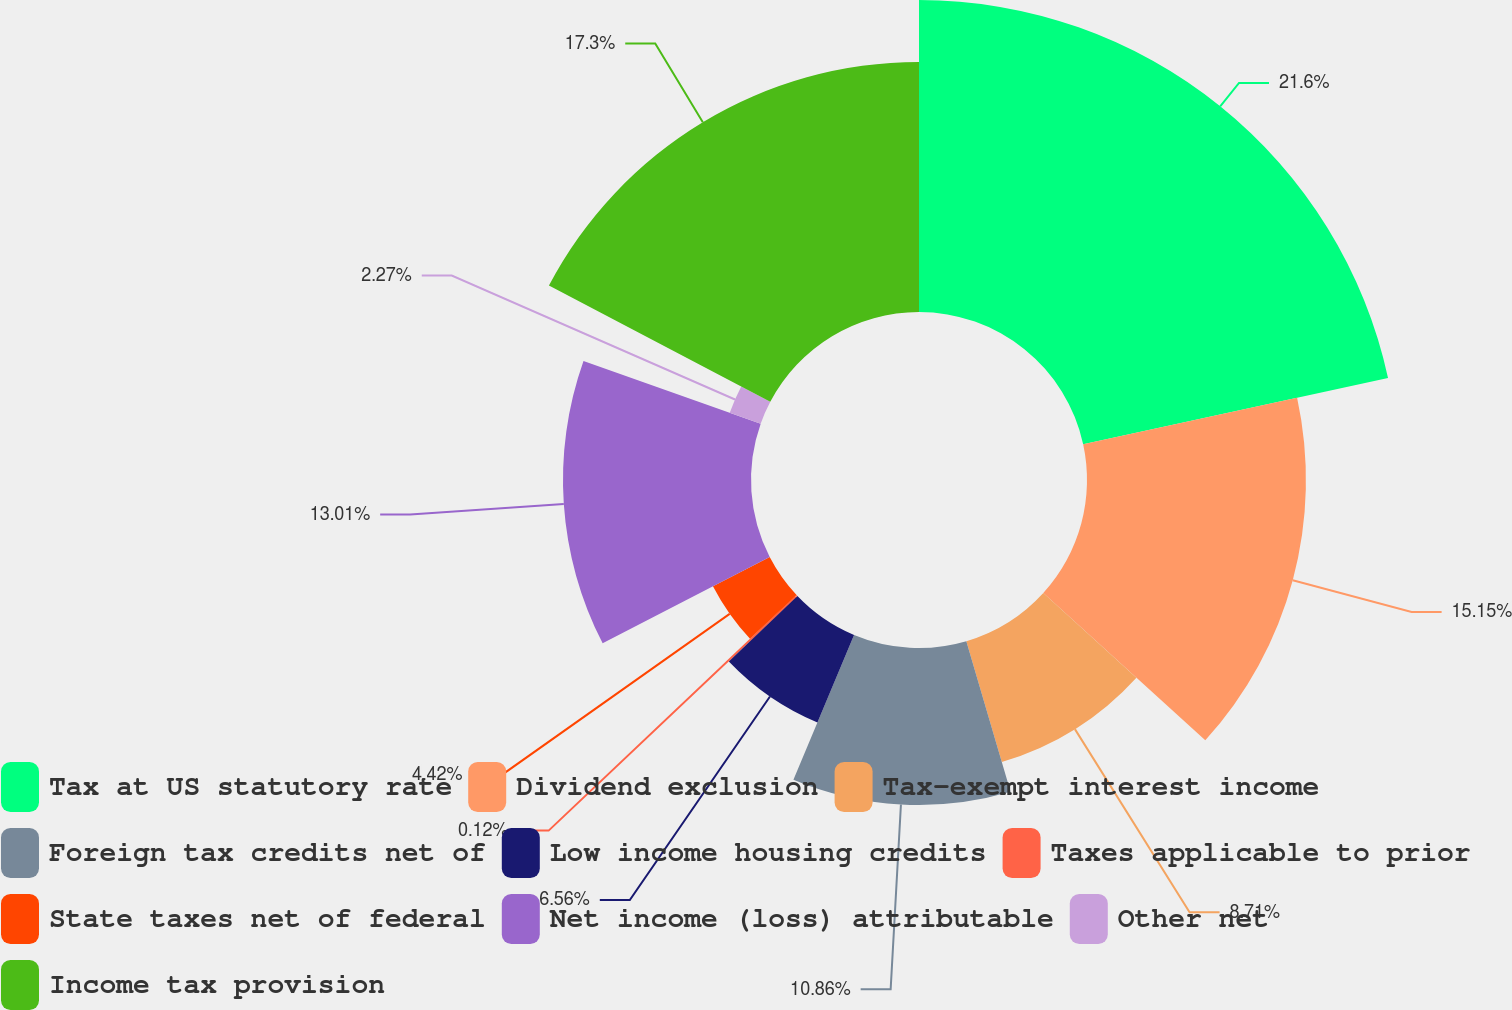Convert chart. <chart><loc_0><loc_0><loc_500><loc_500><pie_chart><fcel>Tax at US statutory rate<fcel>Dividend exclusion<fcel>Tax-exempt interest income<fcel>Foreign tax credits net of<fcel>Low income housing credits<fcel>Taxes applicable to prior<fcel>State taxes net of federal<fcel>Net income (loss) attributable<fcel>Other net<fcel>Income tax provision<nl><fcel>21.59%<fcel>15.15%<fcel>8.71%<fcel>10.86%<fcel>6.56%<fcel>0.12%<fcel>4.42%<fcel>13.01%<fcel>2.27%<fcel>17.3%<nl></chart> 